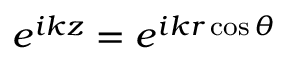<formula> <loc_0><loc_0><loc_500><loc_500>e ^ { i k z } = e ^ { i k r \cos \theta }</formula> 